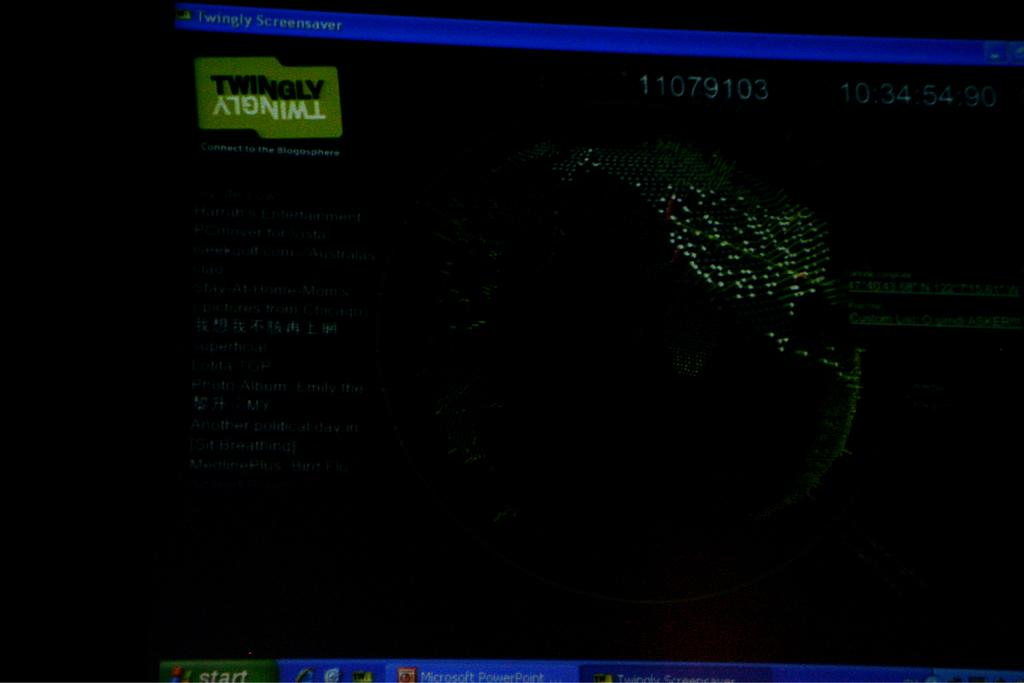<image>
Render a clear and concise summary of the photo. Dark screen showing the number 11079103 on top of a drawing of Earth. 